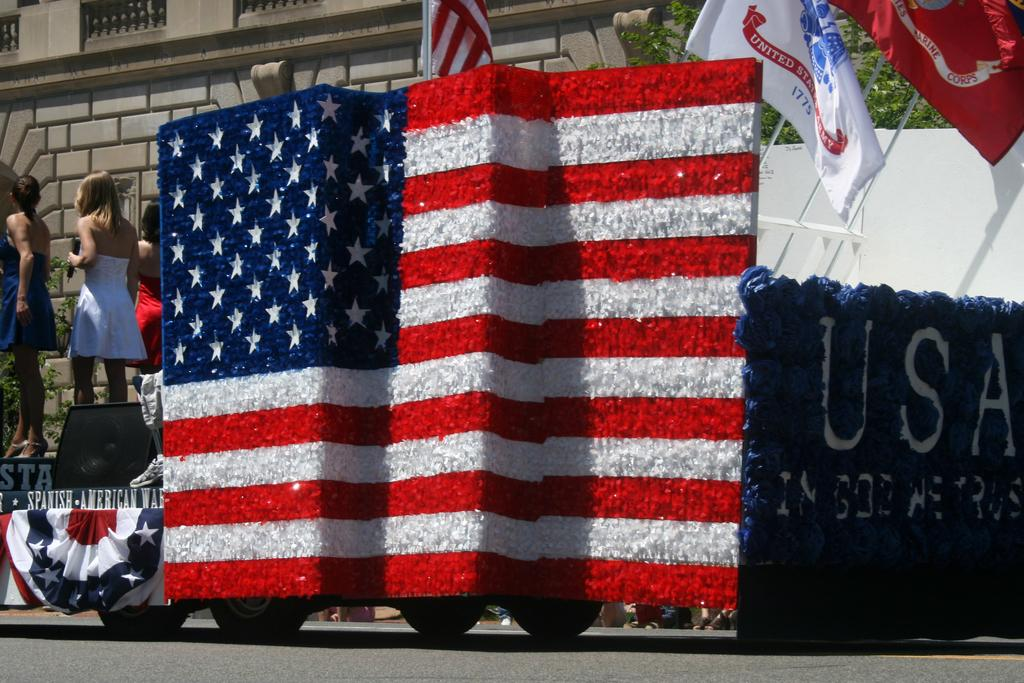<image>
Summarize the visual content of the image. A USA flag is being shown on this float. 